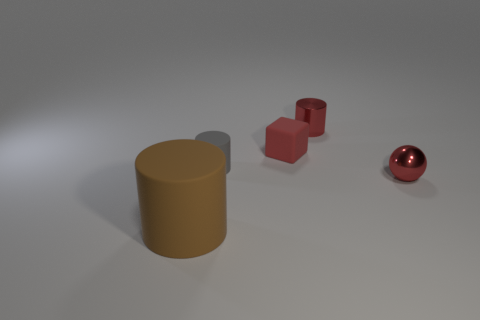What number of small rubber objects have the same color as the big rubber cylinder?
Ensure brevity in your answer.  0. Is there any other thing that has the same material as the big brown object?
Offer a very short reply. Yes. Is the number of tiny shiny spheres that are on the left side of the small cube less than the number of purple rubber spheres?
Your response must be concise. No. There is a rubber cylinder that is on the right side of the rubber thing left of the gray object; what is its color?
Give a very brief answer. Gray. There is a rubber cylinder that is left of the tiny cylinder on the left side of the small red metallic object that is behind the small cube; what is its size?
Keep it short and to the point. Large. Are there fewer big brown cylinders to the right of the small red cylinder than brown objects that are on the right side of the gray matte thing?
Your answer should be compact. No. How many brown cylinders have the same material as the small red block?
Your answer should be compact. 1. Are there any objects that are to the right of the small object that is in front of the tiny cylinder that is in front of the red metallic cylinder?
Your answer should be compact. No. There is a tiny gray thing that is the same material as the large brown cylinder; what shape is it?
Provide a succinct answer. Cylinder. Is the number of big brown matte things greater than the number of tiny matte things?
Offer a terse response. No. 